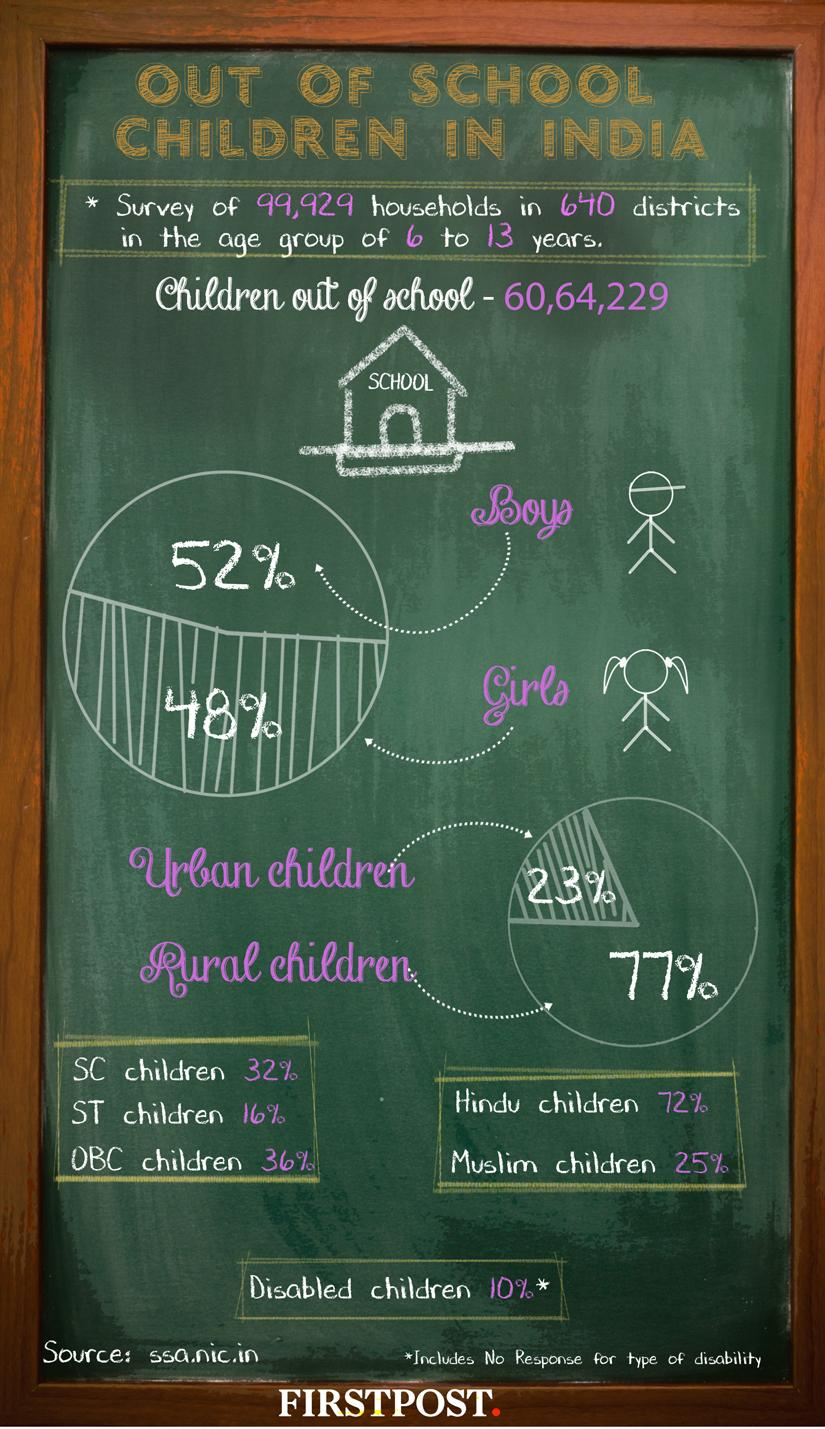Outline some significant characteristics in this image. There are 48 SC/ST children. According to recent data, approximately 90% of children do not have any kind of disability. 